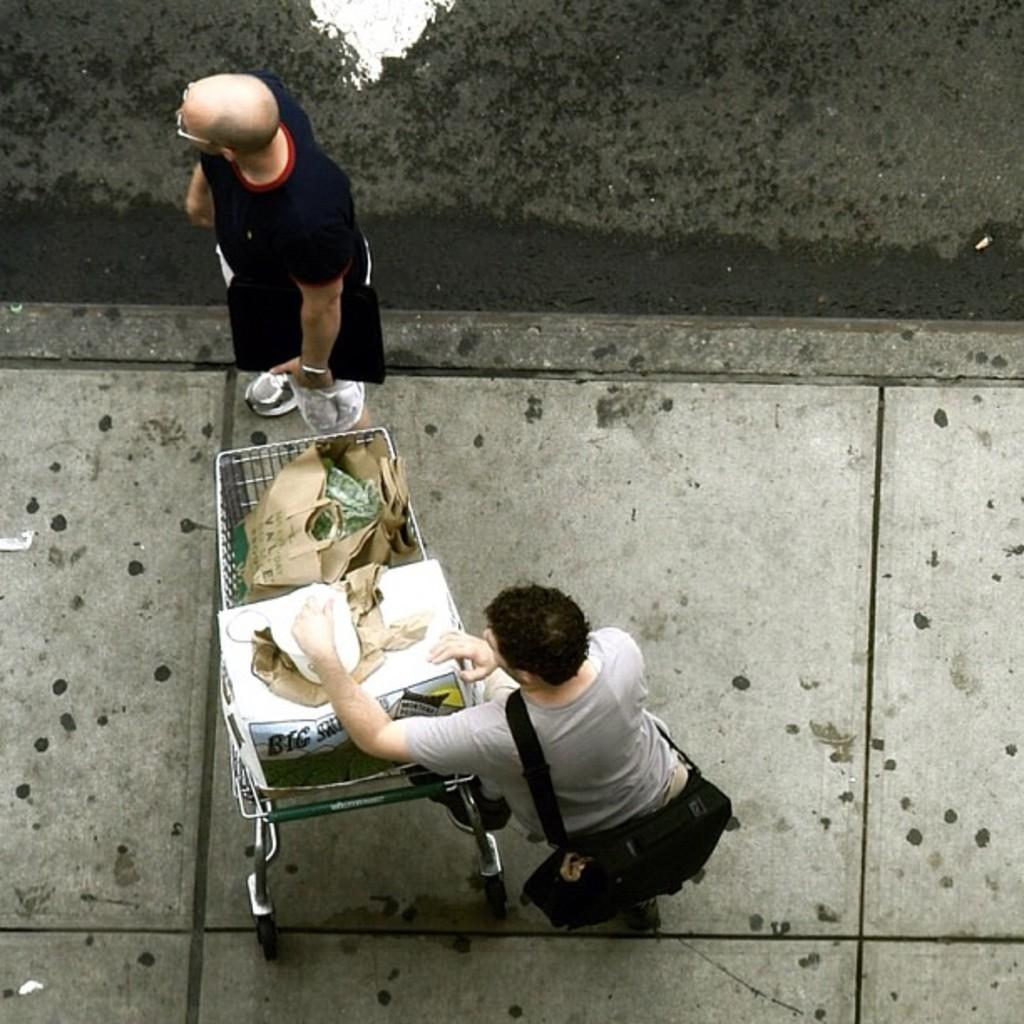How many people are in the image? There are two people in the image. What else can be seen in the image besides the people? There is a cart in the image. What is the purpose of the cart? The cart contains things. Can you describe the attire of one of the men? One of the men is wearing a bag. Where is the kitty taking a bath in the image? There is no kitty present in the image, and therefore no bathing activity can be observed. 